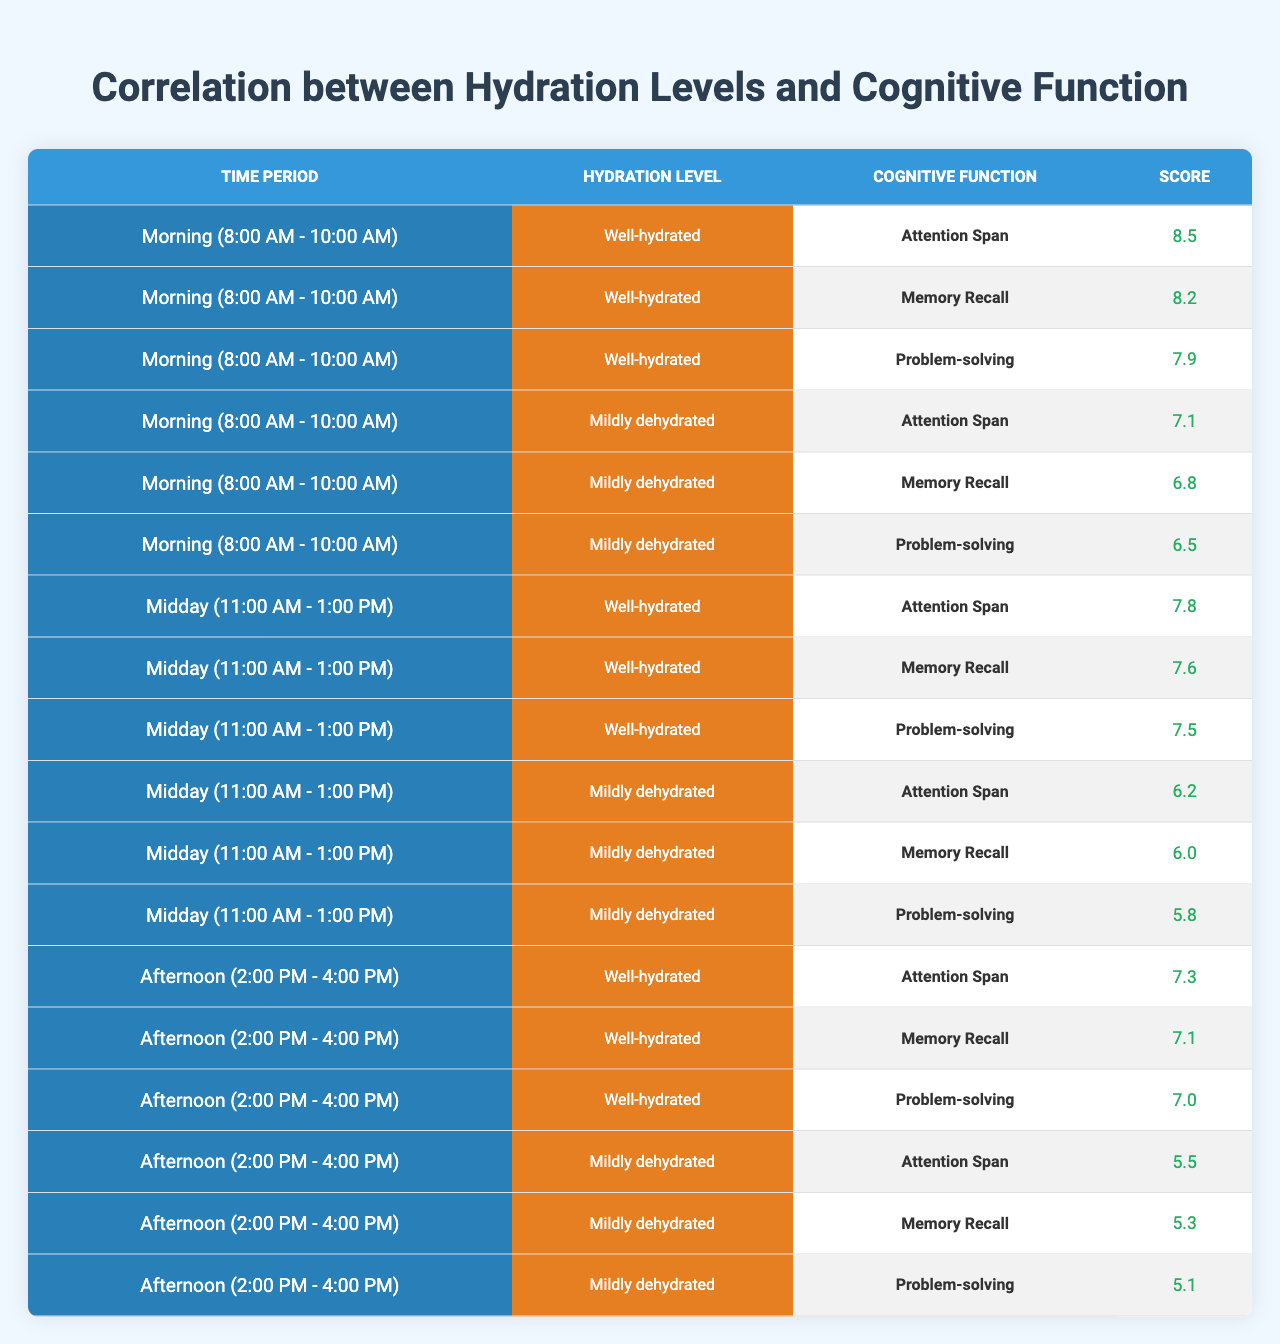What is the cognitive function score for Attention Span during the Morning period when well-hydrated? In the "Morning" period under "Well-hydrated," the score for Attention Span is listed as 8.5.
Answer: 8.5 What was the Memory Recall score for students who were mildly dehydrated during the Afternoon period? In the "Afternoon" period under "Mildly dehydrated," the Memory Recall score is 5.3.
Answer: 5.3 Which cognitive function had the lowest score during the Midday period for mildly dehydrated students? In the Midday period for "Mildly dehydrated," the cognitive function with the lowest score is Problem-solving, which is 5.8.
Answer: Problem-solving Is the Attention Span score higher in the Well-hydrated Afternoon period compared to the Mildly dehydrated Morning period? The Attention Span score for Well-hydrated Afternoon is 7.3 and for Mildly dehydrated Morning is 7.1. Since 7.3 is greater than 7.1, the answer is yes.
Answer: Yes What is the average score for Problem-solving across all periods for well-hydrated students? The Problem-solving scores for well-hydrated students in each period are: Morning (7.9), Midday (7.5), Afternoon (7.0). The total is 7.9 + 7.5 + 7.0 = 22.4, and there are 3 periods; thus, the average is 22.4 / 3 = 7.47.
Answer: 7.47 How much lower is the Memory Recall score in the Mildly dehydrated state during the Midday period compared to the Well-hydrated state during the same period? The Memory Recall score for Mildly dehydrated during Midday is 6.0, and for Well-hydrated is 7.6. The difference is 7.6 - 6.0 = 1.6.
Answer: 1.6 What are the Cognitive Function scores when students are well-hydrated during the Afternoon period? The scores are: Attention Span 7.3, Memory Recall 7.1, and Problem-solving 7.0.
Answer: Attention Span: 7.3, Memory Recall: 7.1, Problem-solving: 7.0 Which time period shows the largest difference in Attention Span score between well-hydrated and mildly dehydrated students? In the Morning, the difference is 8.5 - 7.1 = 1.4; in Midday, it is 7.8 - 6.2 = 1.6; in Afternoon, it is 7.3 - 5.5 = 1.8. The largest difference is in the Afternoon.
Answer: Afternoon What percentage of the maximum score (assumed to be 10) does the Memory Recall score reach for mildly dehydrated students in the Morning period? The Memory Recall score for Mildly dehydrated in the Morning is 6.8. To find the percentage of the maximum score: (6.8 / 10) * 100 = 68%.
Answer: 68% Is the average score of well-hydrated students during Morning higher than the average score of mildly dehydrated students during the Afternoon? The average for well-hydrated Morning is (8.5 + 8.2 + 7.9) / 3 = 8.2. The average for mildly dehydrated Afternoon is (5.5 + 5.3 + 5.1) / 3 = 5.3. Since 8.2 > 5.3, the answer is yes.
Answer: Yes 